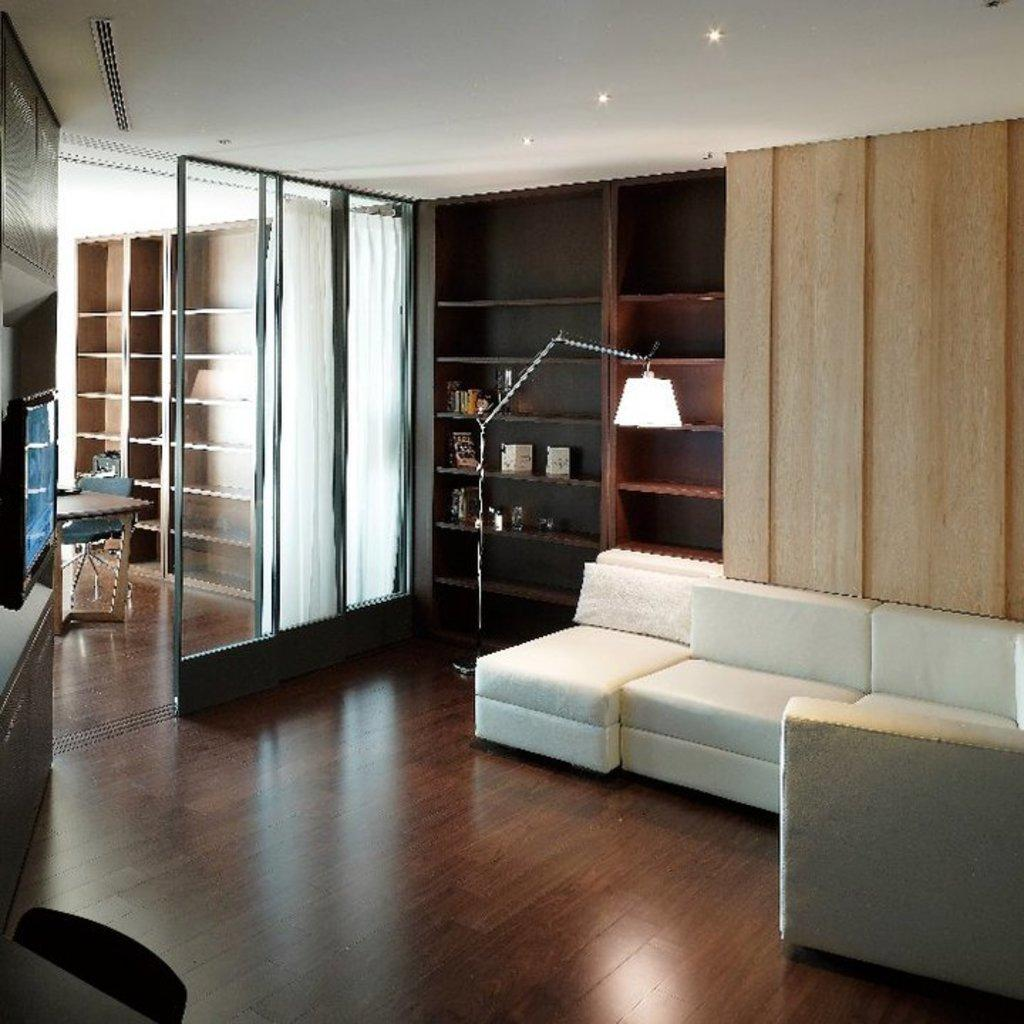What type of seating is available in the room? There is a sofa and a chair in the room. What can be used for illumination in the room? There is a light in the room. What is used for storage in the room? There are racks in the room. What can be used for privacy or light control in the room? There are curtains in the room. What can be used for placing objects in the room? There is a table in the room. What is the material of the floor in the room? The floor is made of wood. What type of religious event is taking place in the room? There is no indication of any religious event taking place in the room; the image only shows furniture and objects. What design style is represented in the room? The image does not provide enough information to determine a specific design style; it only shows the presence of a sofa, chair, light, racks, curtains, table, and wooden floor. 